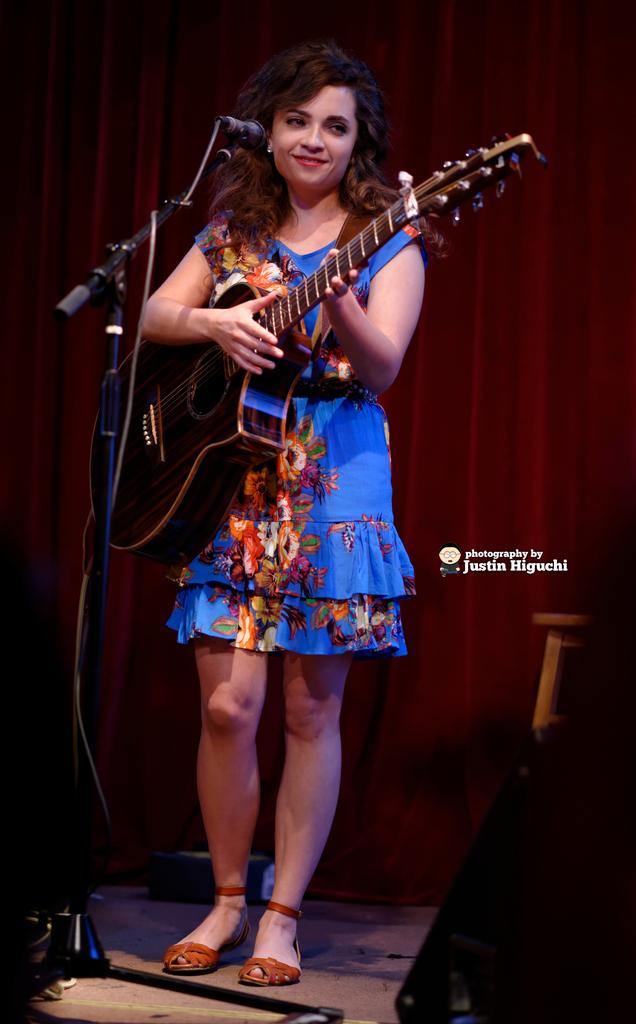What is the woman in the image doing? The woman is playing a guitar. What is the woman standing in front of? The woman is in front of a microphone. Where is the woman performing? The woman is standing on a stage. What color is the dress the woman is wearing? The woman is wearing a blue dress. Can you see any grass in the image? No, there is no grass visible in the image. 